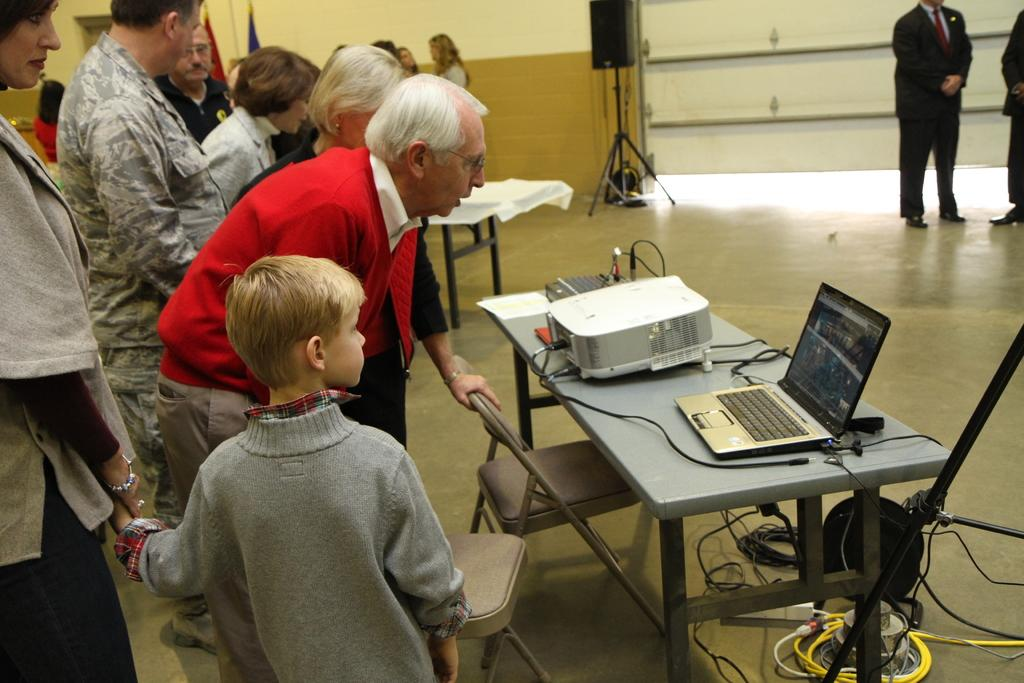What is the main object on the table in the image? A laptop is present on the table. What are the people near the table doing? The people standing near the table are looking at the laptop. What can be seen in the background of the image? There is a wall in the background of the image, and people are standing and talking. How many books can be seen on the table in the image? There are no books visible on the table in the image. What type of jelly is being served to the people in the image? There is no jelly present in the image. 